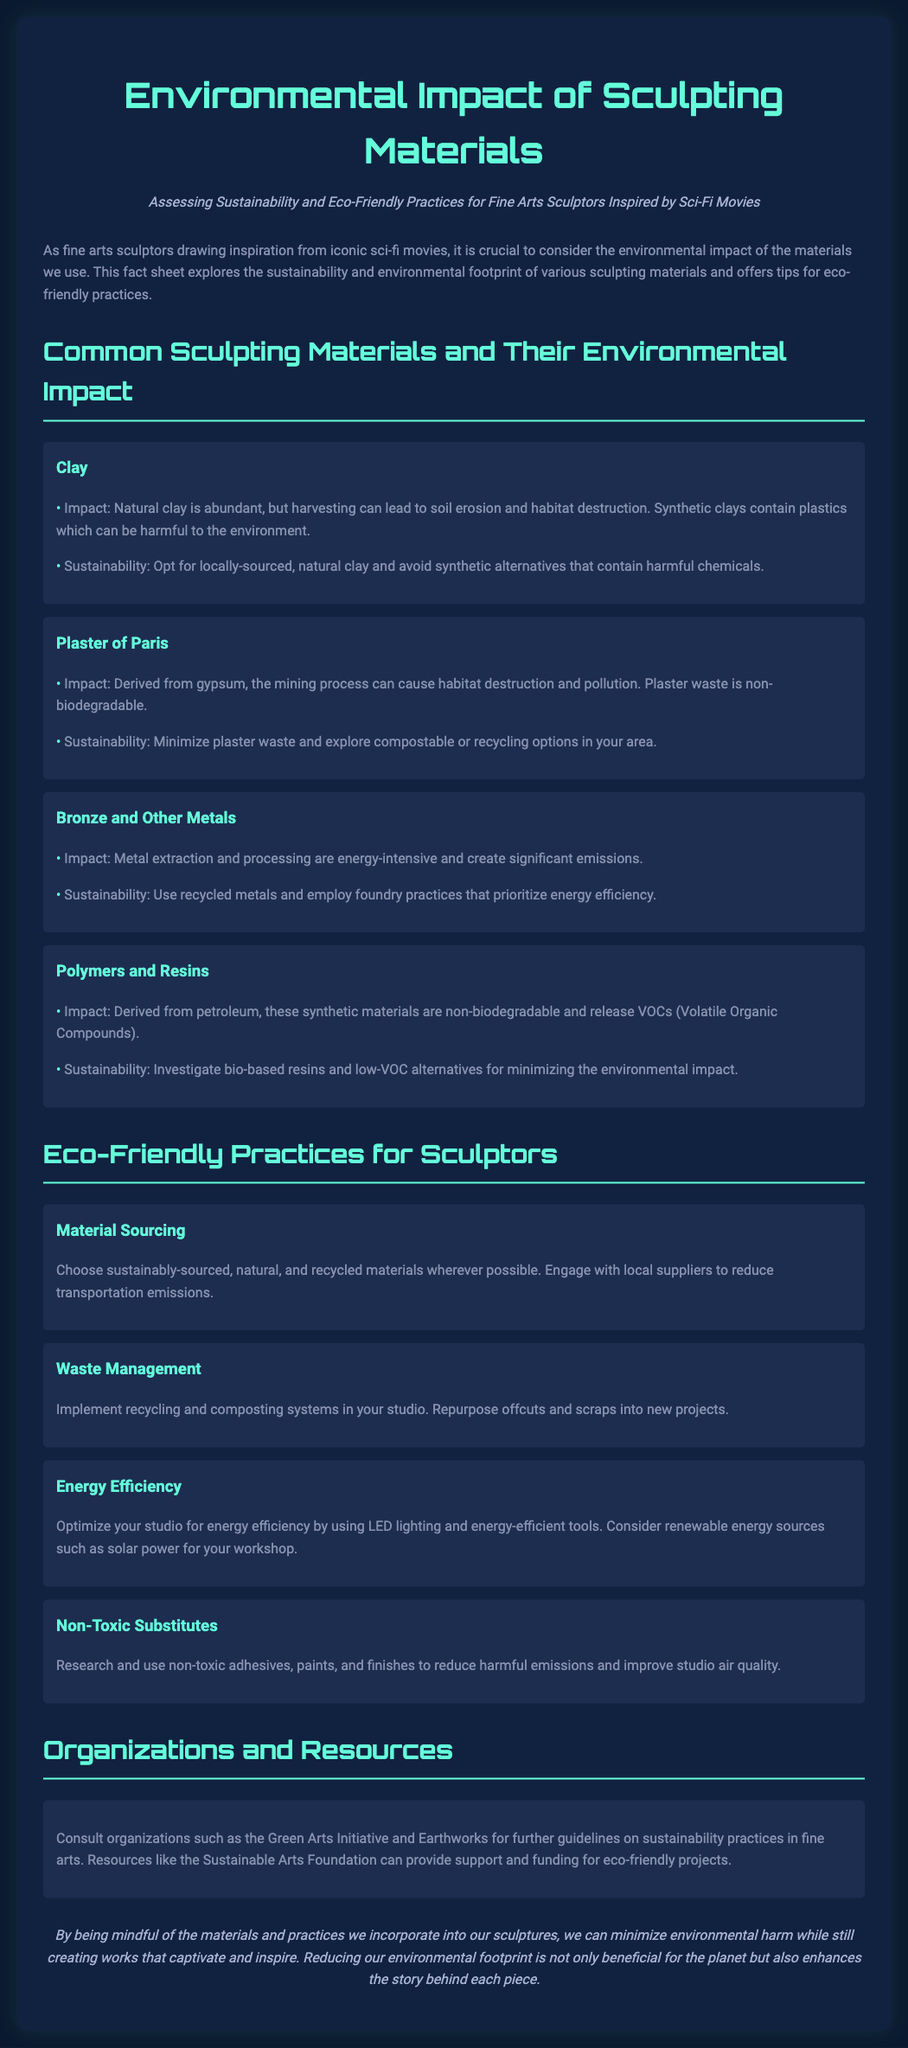What is the impact of clay? The impact of clay states that natural clay is abundant, but harvesting can lead to soil erosion and habitat destruction.
Answer: Soil erosion and habitat destruction What is a sustainable practice for plaster of Paris? The sustainability aspect for plaster of Paris suggests minimizing waste and exploring compostable or recycling options in your area.
Answer: Minimize waste What material is derived from petroleum? The document mentions that polymers and resins are derived from petroleum.
Answer: Polymers and resins What type of lighting is recommended for energy efficiency? The document suggests using LED lighting for optimizing energy efficiency in the studio.
Answer: LED lighting Which organization can be consulted for sustainability practices? The document lists the Green Arts Initiative as an organization to consult for sustainability practices.
Answer: Green Arts Initiative What is a key eco-friendly practice for material sourcing? The detail for material sourcing emphasizes choosing sustainably-sourced, natural, and recycled materials wherever possible.
Answer: Sustainably-sourced materials How does metal extraction impact the environment? The impact of bronze and metals indicates that metal extraction and processing are energy-intensive and create significant emissions.
Answer: Energy-intensive emissions What should be used instead of toxic adhesives? The document recommends researching and using non-toxic substitutes for adhesives.
Answer: Non-toxic substitutes 